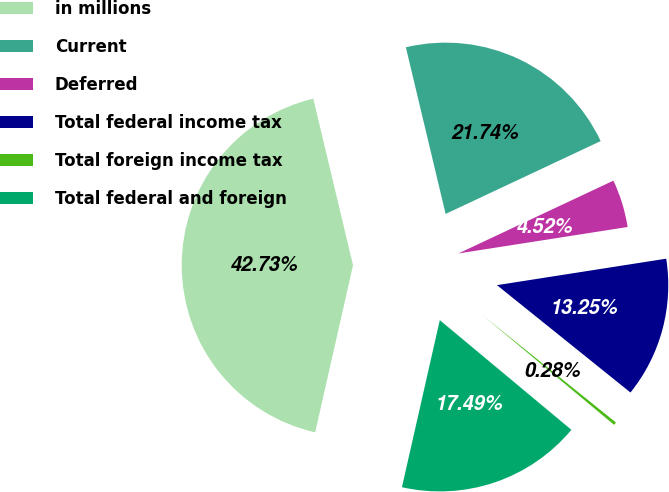Convert chart to OTSL. <chart><loc_0><loc_0><loc_500><loc_500><pie_chart><fcel>in millions<fcel>Current<fcel>Deferred<fcel>Total federal income tax<fcel>Total foreign income tax<fcel>Total federal and foreign<nl><fcel>42.73%<fcel>21.74%<fcel>4.52%<fcel>13.25%<fcel>0.28%<fcel>17.49%<nl></chart> 